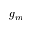Convert formula to latex. <formula><loc_0><loc_0><loc_500><loc_500>g _ { m }</formula> 